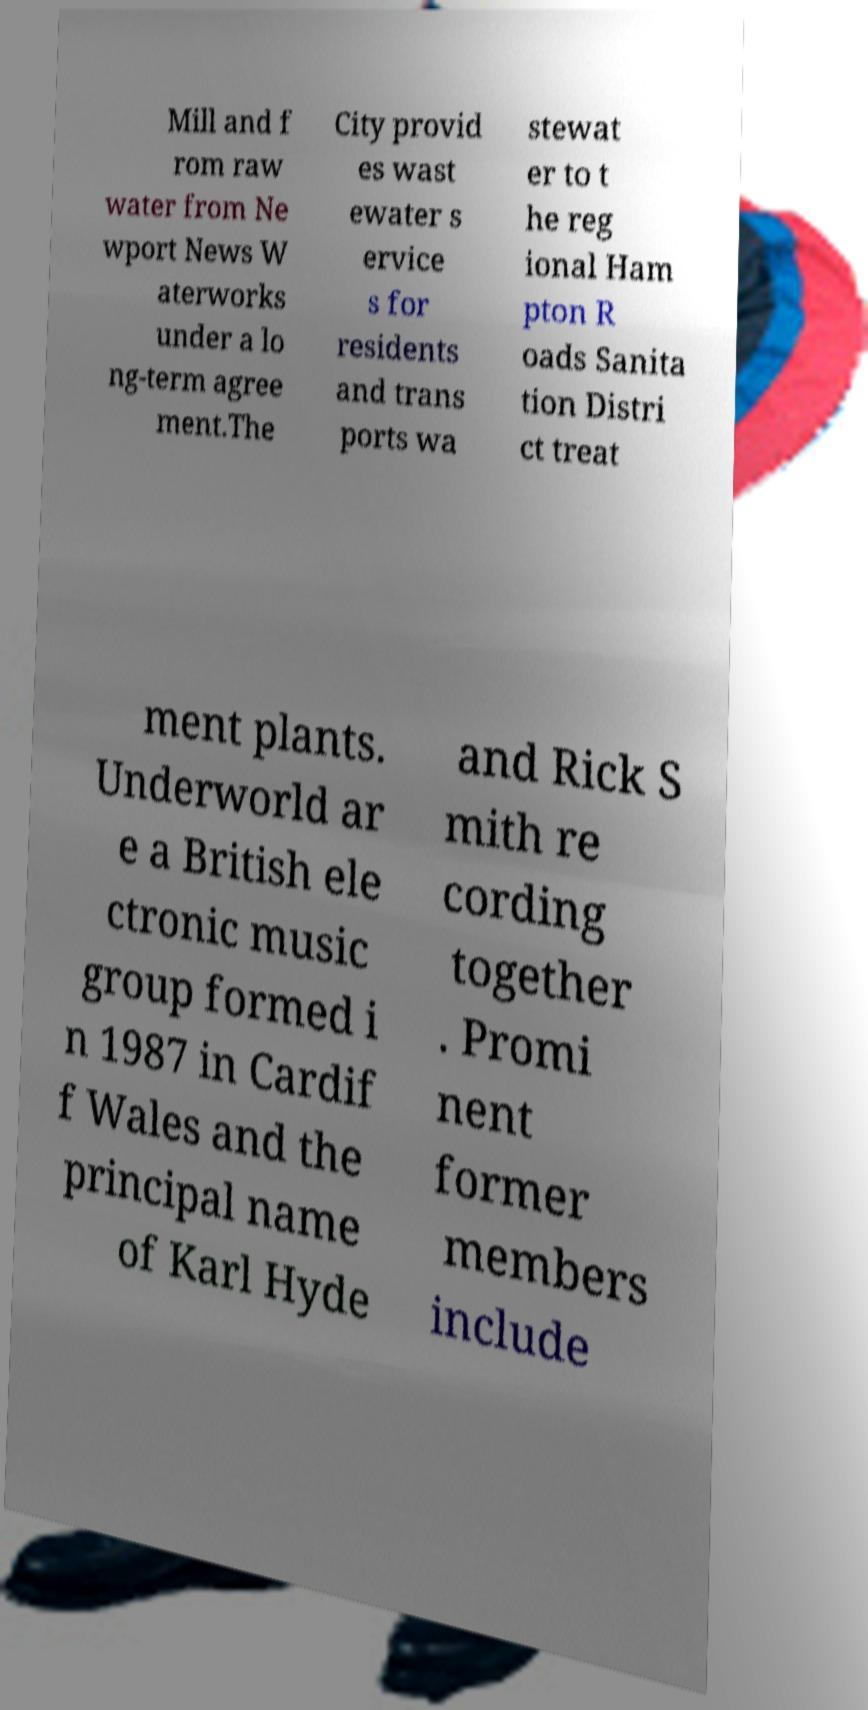There's text embedded in this image that I need extracted. Can you transcribe it verbatim? Mill and f rom raw water from Ne wport News W aterworks under a lo ng-term agree ment.The City provid es wast ewater s ervice s for residents and trans ports wa stewat er to t he reg ional Ham pton R oads Sanita tion Distri ct treat ment plants. Underworld ar e a British ele ctronic music group formed i n 1987 in Cardif f Wales and the principal name of Karl Hyde and Rick S mith re cording together . Promi nent former members include 